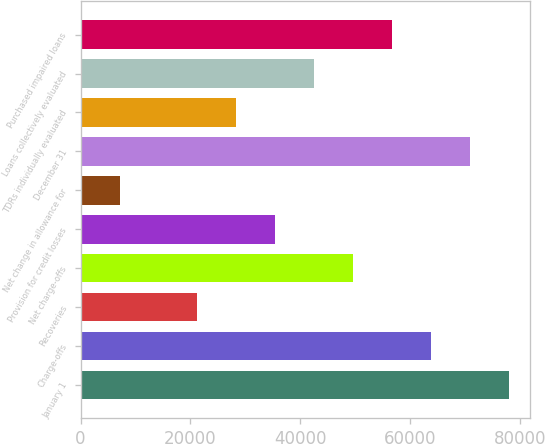Convert chart to OTSL. <chart><loc_0><loc_0><loc_500><loc_500><bar_chart><fcel>January 1<fcel>Charge-offs<fcel>Recoveries<fcel>Net charge-offs<fcel>Provision for credit losses<fcel>Net change in allowance for<fcel>December 31<fcel>TDRs individually evaluated<fcel>Loans collectively evaluated<fcel>Purchased impaired loans<nl><fcel>77961.2<fcel>63786.9<fcel>21264<fcel>49612.6<fcel>35438.3<fcel>7089.77<fcel>70874<fcel>28351.2<fcel>42525.5<fcel>56699.8<nl></chart> 